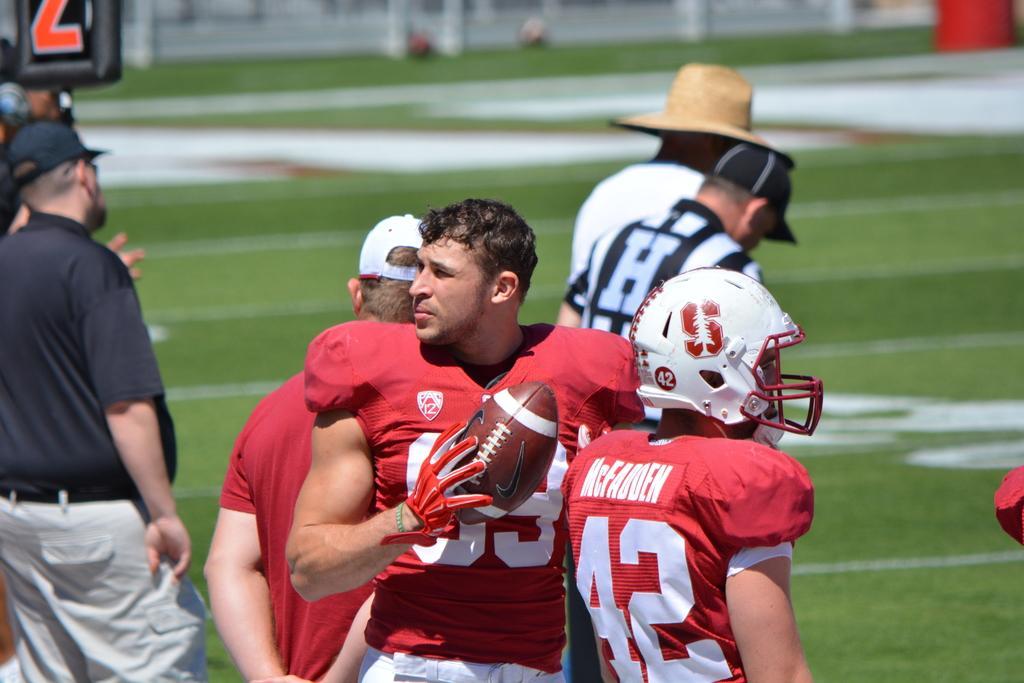In one or two sentences, can you explain what this image depicts? In this image we can see many people. Some are wearing caps. One person is wearing hat. Another person is wearing helmet. One person is wearing glove hand holding ball. On the ground there is grass. In the background it is blur. 